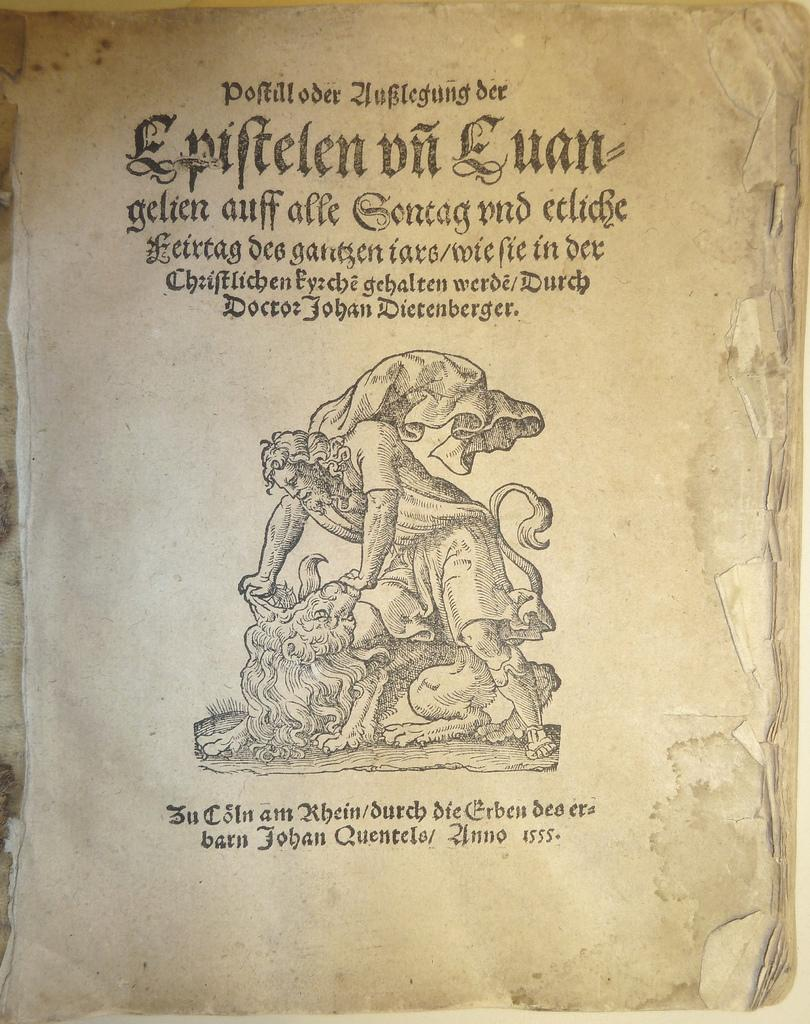Provide a one-sentence caption for the provided image. A page from an old book that says Doctor Johan Dietenberger right on top of the drawn figure. 